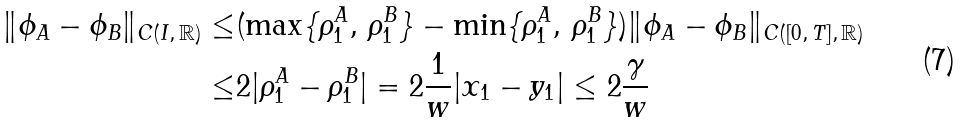Convert formula to latex. <formula><loc_0><loc_0><loc_500><loc_500>\| \phi _ { A } - \phi _ { B } \| _ { C ( I , \, \mathbb { R } ) } \leq & ( \max \{ \rho _ { 1 } ^ { A } , \, \rho _ { 1 } ^ { B } \} - \min \{ \rho _ { 1 } ^ { A } , \, \rho _ { 1 } ^ { B } \} ) \| \phi _ { A } - \phi _ { B } \| _ { C ( [ 0 , \, T ] , \, \mathbb { R } ) } \\ \leq & 2 | \rho _ { 1 } ^ { A } - \rho _ { 1 } ^ { B } | = 2 \frac { 1 } { w } | x _ { 1 } - y _ { 1 } | \leq 2 \frac { \gamma } { w }</formula> 